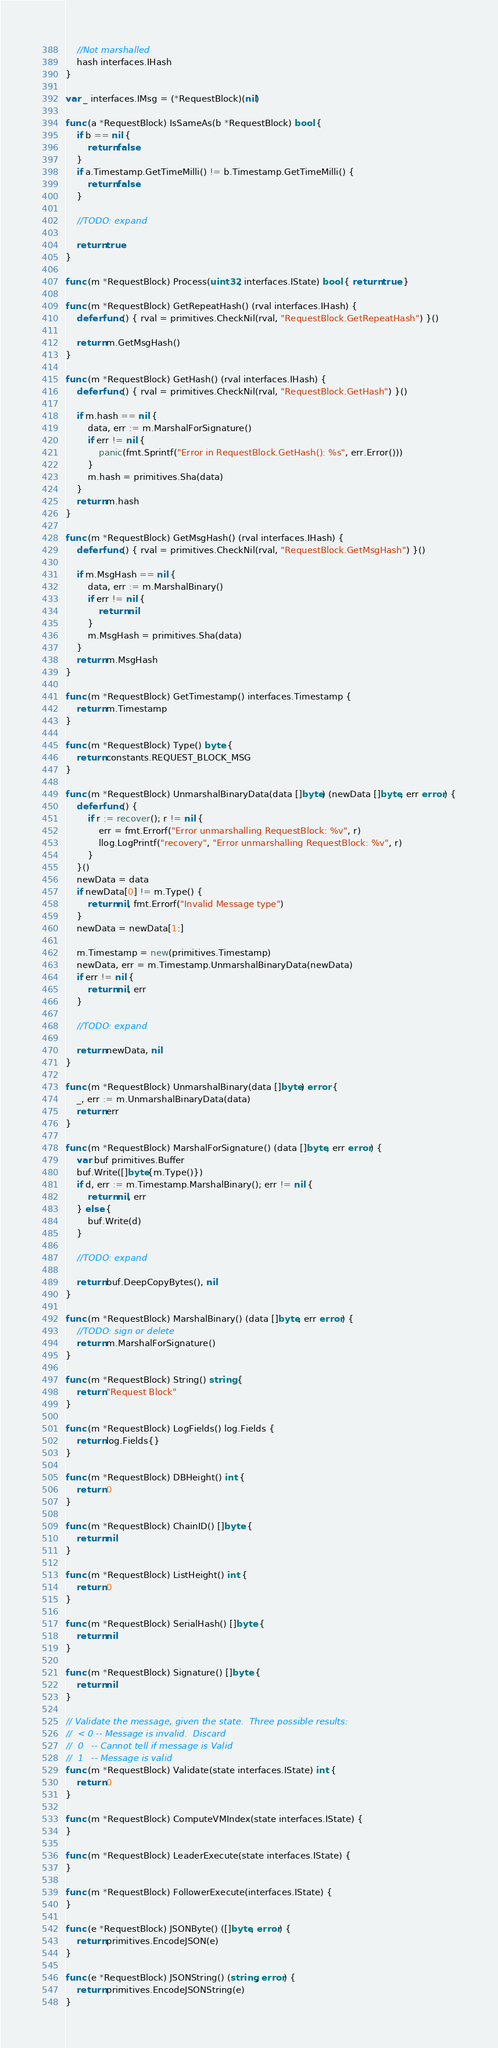<code> <loc_0><loc_0><loc_500><loc_500><_Go_>	//Not marshalled
	hash interfaces.IHash
}

var _ interfaces.IMsg = (*RequestBlock)(nil)

func (a *RequestBlock) IsSameAs(b *RequestBlock) bool {
	if b == nil {
		return false
	}
	if a.Timestamp.GetTimeMilli() != b.Timestamp.GetTimeMilli() {
		return false
	}

	//TODO: expand

	return true
}

func (m *RequestBlock) Process(uint32, interfaces.IState) bool { return true }

func (m *RequestBlock) GetRepeatHash() (rval interfaces.IHash) {
	defer func() { rval = primitives.CheckNil(rval, "RequestBlock.GetRepeatHash") }()

	return m.GetMsgHash()
}

func (m *RequestBlock) GetHash() (rval interfaces.IHash) {
	defer func() { rval = primitives.CheckNil(rval, "RequestBlock.GetHash") }()

	if m.hash == nil {
		data, err := m.MarshalForSignature()
		if err != nil {
			panic(fmt.Sprintf("Error in RequestBlock.GetHash(): %s", err.Error()))
		}
		m.hash = primitives.Sha(data)
	}
	return m.hash
}

func (m *RequestBlock) GetMsgHash() (rval interfaces.IHash) {
	defer func() { rval = primitives.CheckNil(rval, "RequestBlock.GetMsgHash") }()

	if m.MsgHash == nil {
		data, err := m.MarshalBinary()
		if err != nil {
			return nil
		}
		m.MsgHash = primitives.Sha(data)
	}
	return m.MsgHash
}

func (m *RequestBlock) GetTimestamp() interfaces.Timestamp {
	return m.Timestamp
}

func (m *RequestBlock) Type() byte {
	return constants.REQUEST_BLOCK_MSG
}

func (m *RequestBlock) UnmarshalBinaryData(data []byte) (newData []byte, err error) {
	defer func() {
		if r := recover(); r != nil {
			err = fmt.Errorf("Error unmarshalling RequestBlock: %v", r)
			llog.LogPrintf("recovery", "Error unmarshalling RequestBlock: %v", r)
		}
	}()
	newData = data
	if newData[0] != m.Type() {
		return nil, fmt.Errorf("Invalid Message type")
	}
	newData = newData[1:]

	m.Timestamp = new(primitives.Timestamp)
	newData, err = m.Timestamp.UnmarshalBinaryData(newData)
	if err != nil {
		return nil, err
	}

	//TODO: expand

	return newData, nil
}

func (m *RequestBlock) UnmarshalBinary(data []byte) error {
	_, err := m.UnmarshalBinaryData(data)
	return err
}

func (m *RequestBlock) MarshalForSignature() (data []byte, err error) {
	var buf primitives.Buffer
	buf.Write([]byte{m.Type()})
	if d, err := m.Timestamp.MarshalBinary(); err != nil {
		return nil, err
	} else {
		buf.Write(d)
	}

	//TODO: expand

	return buf.DeepCopyBytes(), nil
}

func (m *RequestBlock) MarshalBinary() (data []byte, err error) {
	//TODO: sign or delete
	return m.MarshalForSignature()
}

func (m *RequestBlock) String() string {
	return "Request Block"
}

func (m *RequestBlock) LogFields() log.Fields {
	return log.Fields{}
}

func (m *RequestBlock) DBHeight() int {
	return 0
}

func (m *RequestBlock) ChainID() []byte {
	return nil
}

func (m *RequestBlock) ListHeight() int {
	return 0
}

func (m *RequestBlock) SerialHash() []byte {
	return nil
}

func (m *RequestBlock) Signature() []byte {
	return nil
}

// Validate the message, given the state.  Three possible results:
//  < 0 -- Message is invalid.  Discard
//  0   -- Cannot tell if message is Valid
//  1   -- Message is valid
func (m *RequestBlock) Validate(state interfaces.IState) int {
	return 0
}

func (m *RequestBlock) ComputeVMIndex(state interfaces.IState) {
}

func (m *RequestBlock) LeaderExecute(state interfaces.IState) {
}

func (m *RequestBlock) FollowerExecute(interfaces.IState) {
}

func (e *RequestBlock) JSONByte() ([]byte, error) {
	return primitives.EncodeJSON(e)
}

func (e *RequestBlock) JSONString() (string, error) {
	return primitives.EncodeJSONString(e)
}
</code> 